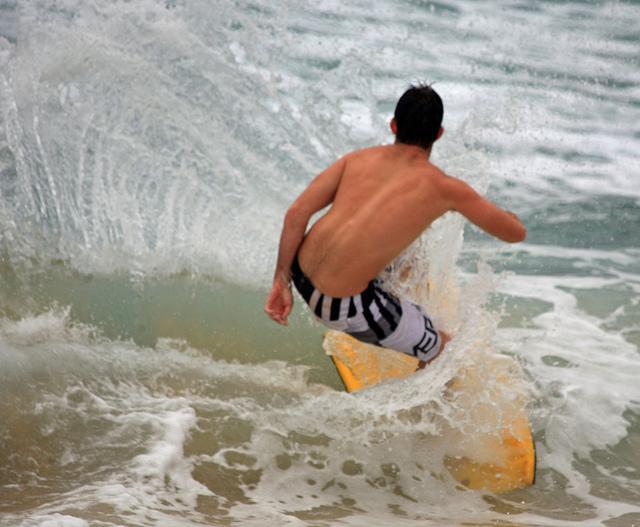Is it a female on the board?
Give a very brief answer. No. What is the color of the surfboard?
Write a very short answer. Yellow. What color is the boogie board?
Be succinct. Yellow. Is he wearing a wetsuit?
Answer briefly. No. Is the surfer skinny?
Give a very brief answer. Yes. What is this boy wearing?
Give a very brief answer. Shorts. 